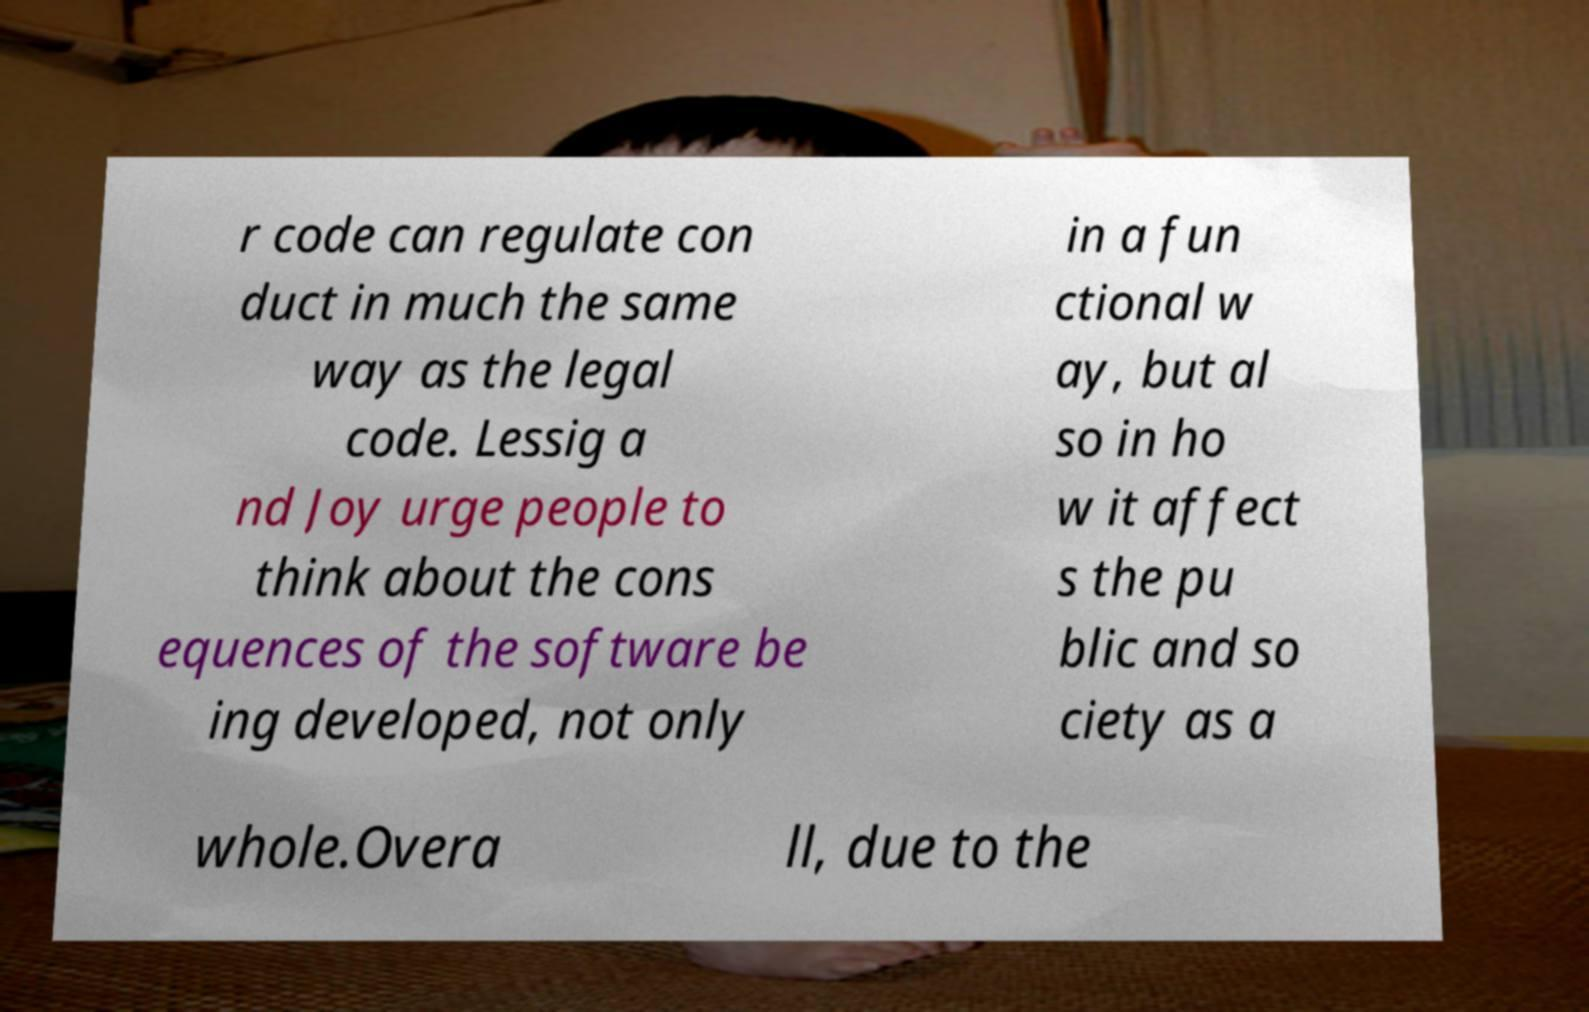Could you extract and type out the text from this image? r code can regulate con duct in much the same way as the legal code. Lessig a nd Joy urge people to think about the cons equences of the software be ing developed, not only in a fun ctional w ay, but al so in ho w it affect s the pu blic and so ciety as a whole.Overa ll, due to the 